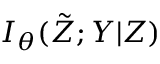Convert formula to latex. <formula><loc_0><loc_0><loc_500><loc_500>I _ { \theta } ( \tilde { Z } ; Y | Z )</formula> 